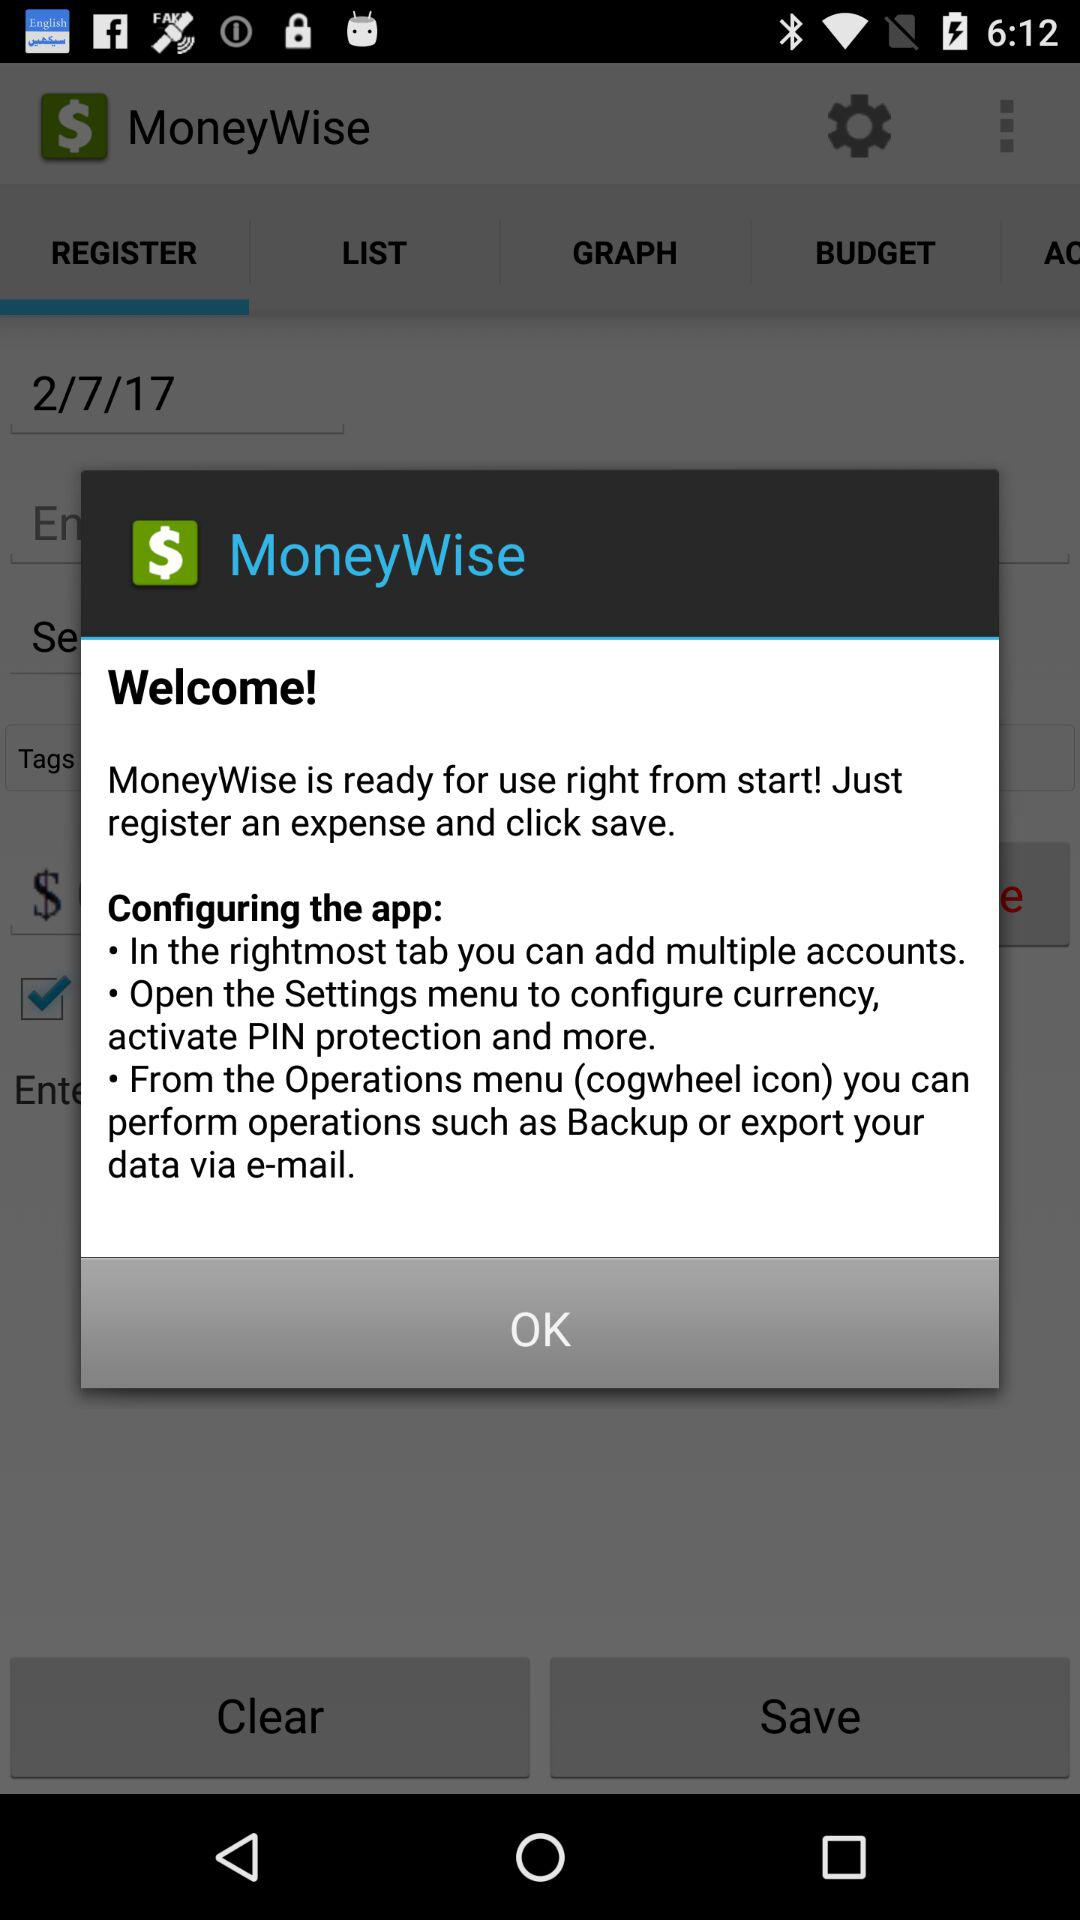What is the date? The date is 2/7/17. 